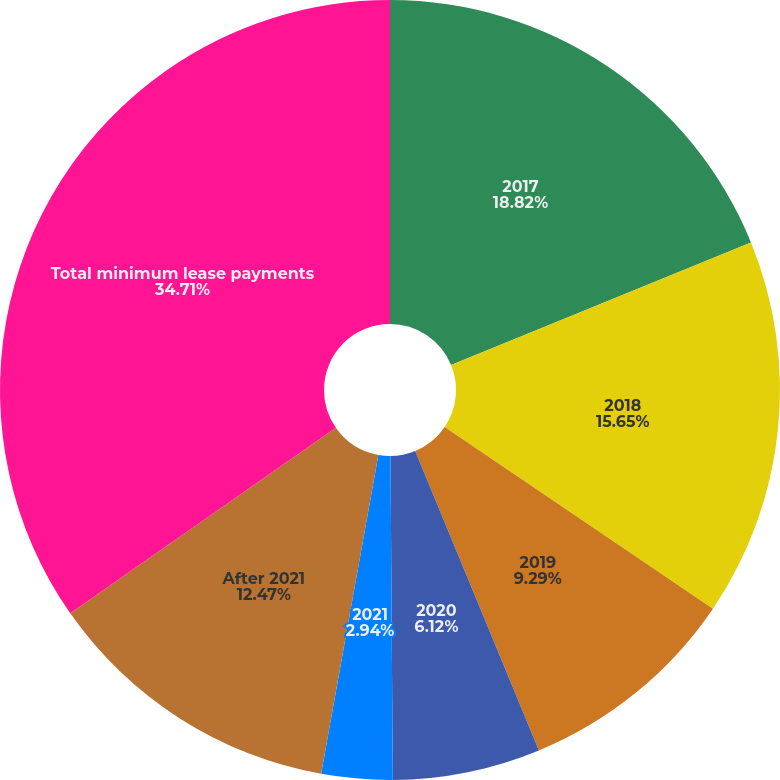Convert chart. <chart><loc_0><loc_0><loc_500><loc_500><pie_chart><fcel>2017<fcel>2018<fcel>2019<fcel>2020<fcel>2021<fcel>After 2021<fcel>Total minimum lease payments<nl><fcel>18.82%<fcel>15.65%<fcel>9.29%<fcel>6.12%<fcel>2.94%<fcel>12.47%<fcel>34.7%<nl></chart> 